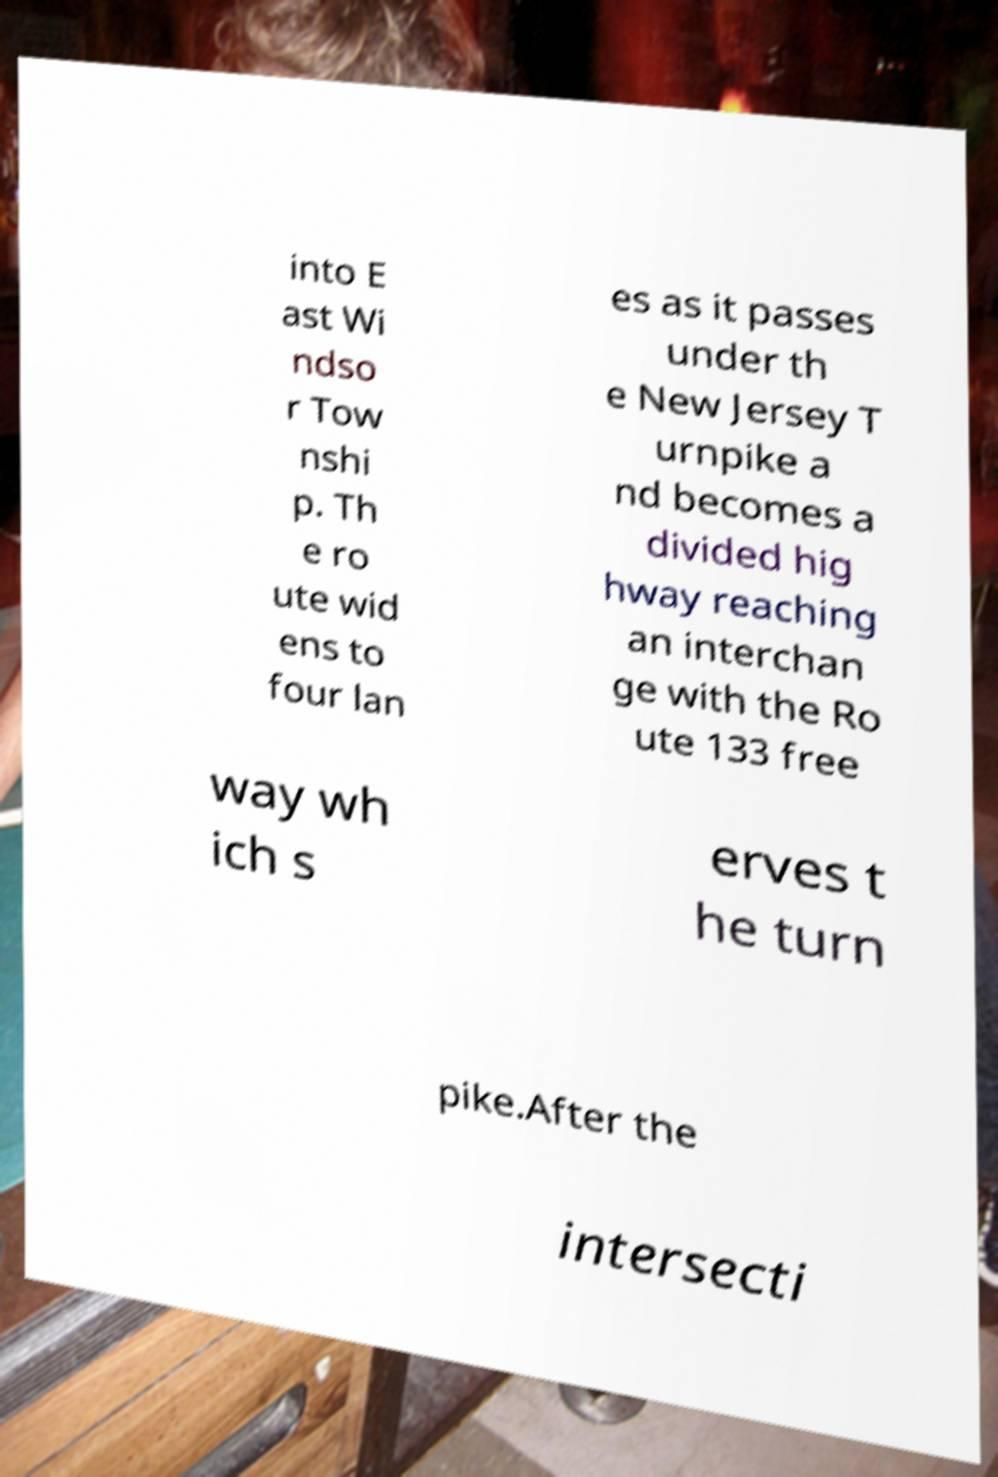Could you extract and type out the text from this image? into E ast Wi ndso r Tow nshi p. Th e ro ute wid ens to four lan es as it passes under th e New Jersey T urnpike a nd becomes a divided hig hway reaching an interchan ge with the Ro ute 133 free way wh ich s erves t he turn pike.After the intersecti 